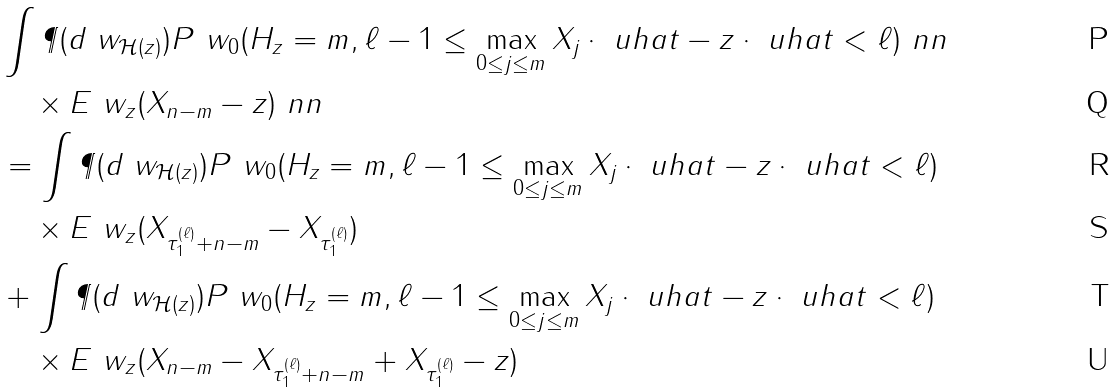<formula> <loc_0><loc_0><loc_500><loc_500>& \int \P ( d \ w _ { { \mathcal { H } } ( z ) } ) P ^ { \ } w _ { 0 } ( H _ { z } = m , \ell - 1 \leq \max _ { 0 \leq j \leq m } X _ { j } \cdot \ u h a t - z \cdot \ u h a t < \ell ) \ n n \\ & \quad \times E ^ { \ } w _ { z } ( X _ { n - m } - z ) \ n n \\ & = \int \P ( d \ w _ { { \mathcal { H } } ( z ) } ) P ^ { \ } w _ { 0 } ( H _ { z } = m , \ell - 1 \leq \max _ { 0 \leq j \leq m } X _ { j } \cdot \ u h a t - z \cdot \ u h a t < \ell ) \\ & \quad \times E ^ { \ } w _ { z } ( X _ { \tau ^ { ( \ell ) } _ { 1 } + n - m } - X _ { \tau ^ { ( \ell ) } _ { 1 } } ) \\ \quad & + \int \P ( d \ w _ { { \mathcal { H } } ( z ) } ) P ^ { \ } w _ { 0 } ( H _ { z } = m , \ell - 1 \leq \max _ { 0 \leq j \leq m } X _ { j } \cdot \ u h a t - z \cdot \ u h a t < \ell ) \\ & \quad \times E ^ { \ } w _ { z } ( X _ { n - m } - X _ { \tau ^ { ( \ell ) } _ { 1 } + n - m } + X _ { \tau ^ { ( \ell ) } _ { 1 } } - z )</formula> 